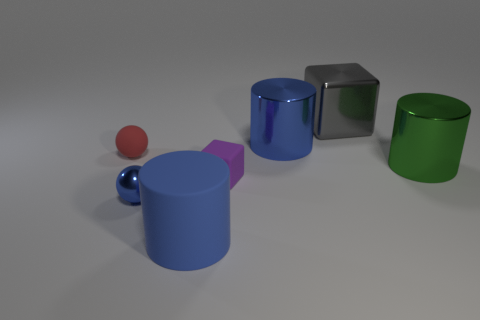There is a metallic cylinder in front of the blue metallic object that is behind the green metallic thing; what size is it?
Make the answer very short. Large. What material is the object that is both behind the small red matte ball and to the left of the large gray metal thing?
Ensure brevity in your answer.  Metal. What number of other objects are the same size as the green metal object?
Offer a terse response. 3. What is the color of the small matte ball?
Make the answer very short. Red. Is the color of the tiny metallic sphere that is in front of the big metal block the same as the big metal cylinder that is on the left side of the shiny block?
Give a very brief answer. Yes. The rubber cylinder has what size?
Offer a very short reply. Large. There is a object in front of the blue shiny sphere; what is its size?
Your response must be concise. Large. There is a thing that is right of the big blue rubber object and in front of the big green metal object; what shape is it?
Your answer should be very brief. Cube. What number of other objects are the same shape as the gray metal object?
Provide a succinct answer. 1. There is a matte cylinder that is the same size as the gray thing; what color is it?
Keep it short and to the point. Blue. 